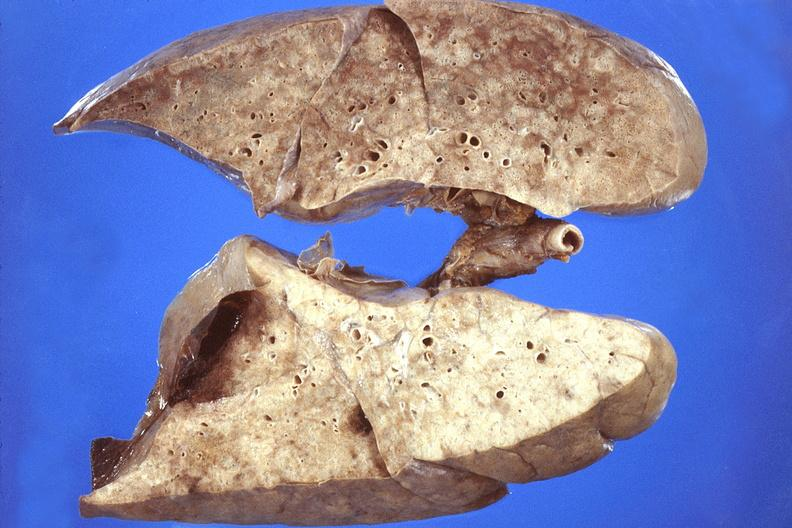s acute inflammation present?
Answer the question using a single word or phrase. No 